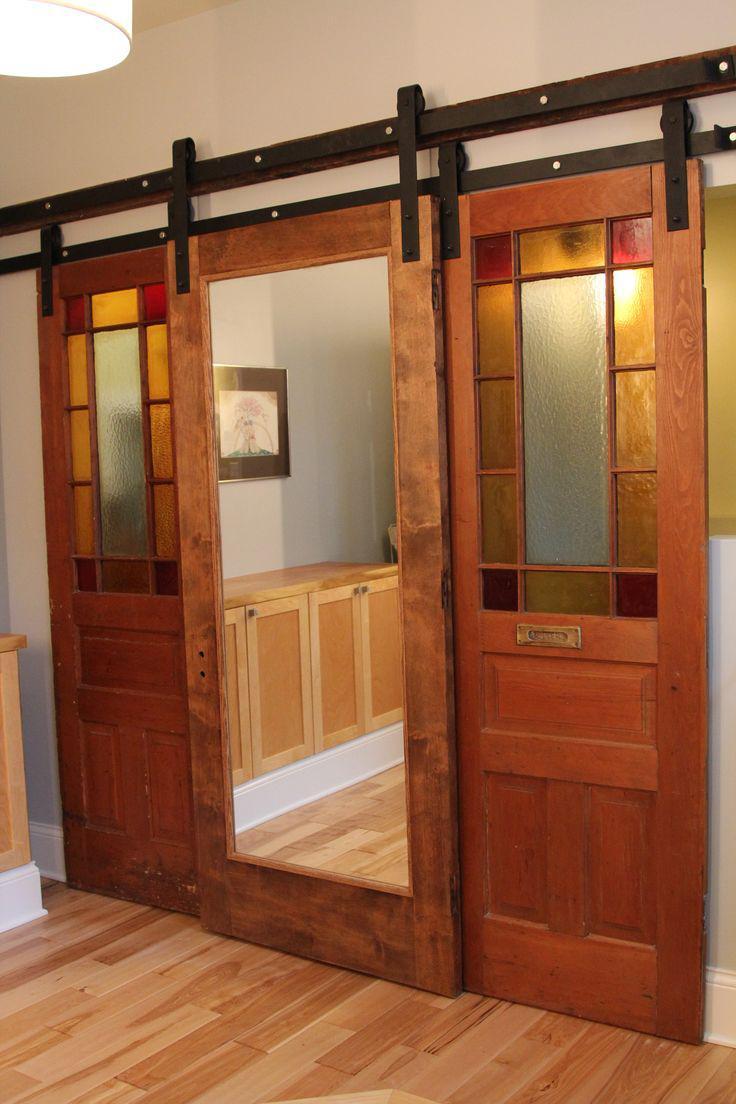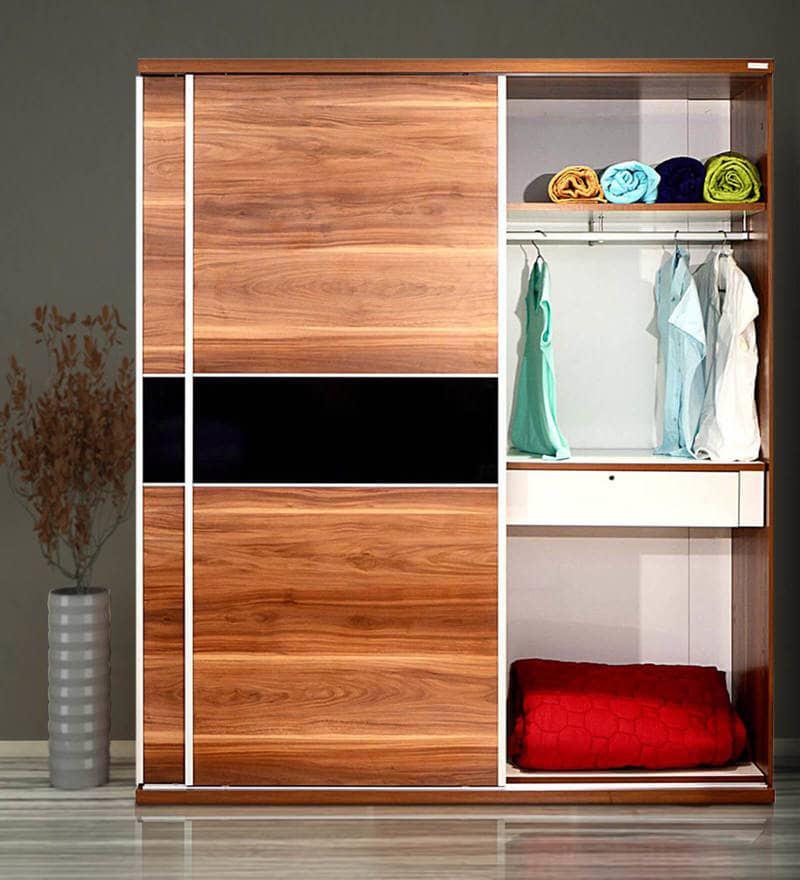The first image is the image on the left, the second image is the image on the right. Given the left and right images, does the statement "One image shows a sliding wood-grain door with a black horizontal band in the center." hold true? Answer yes or no. Yes. The first image is the image on the left, the second image is the image on the right. Assess this claim about the two images: "In one image, a wooden free-standing wardrobe has sliding doors, one of which is open.". Correct or not? Answer yes or no. Yes. 